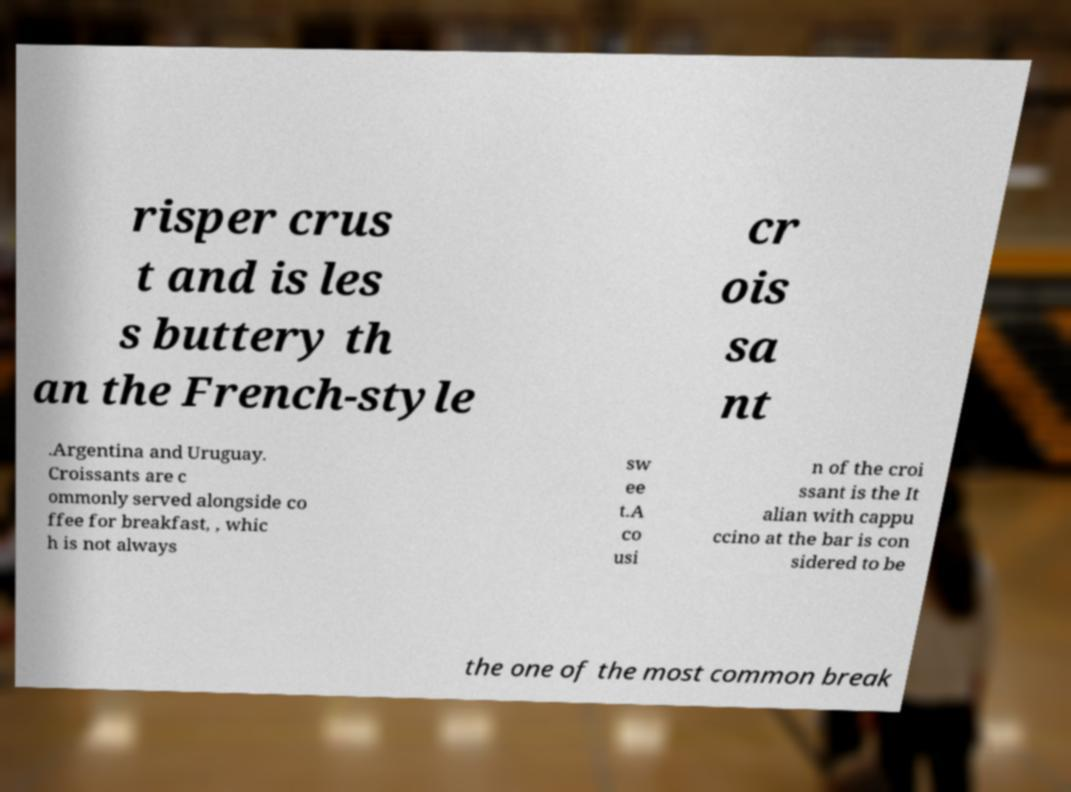What messages or text are displayed in this image? I need them in a readable, typed format. risper crus t and is les s buttery th an the French-style cr ois sa nt .Argentina and Uruguay. Croissants are c ommonly served alongside co ffee for breakfast, , whic h is not always sw ee t.A co usi n of the croi ssant is the It alian with cappu ccino at the bar is con sidered to be the one of the most common break 